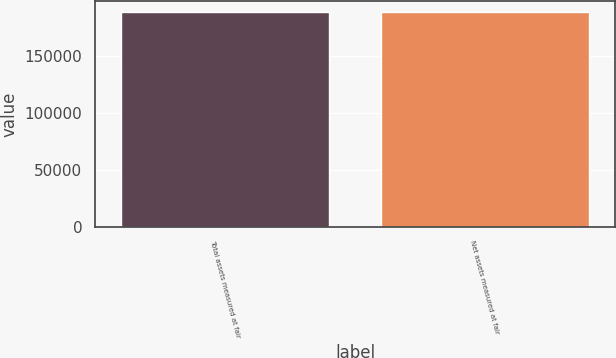Convert chart. <chart><loc_0><loc_0><loc_500><loc_500><bar_chart><fcel>Total assets measured at fair<fcel>Net assets measured at fair<nl><fcel>188733<fcel>188733<nl></chart> 